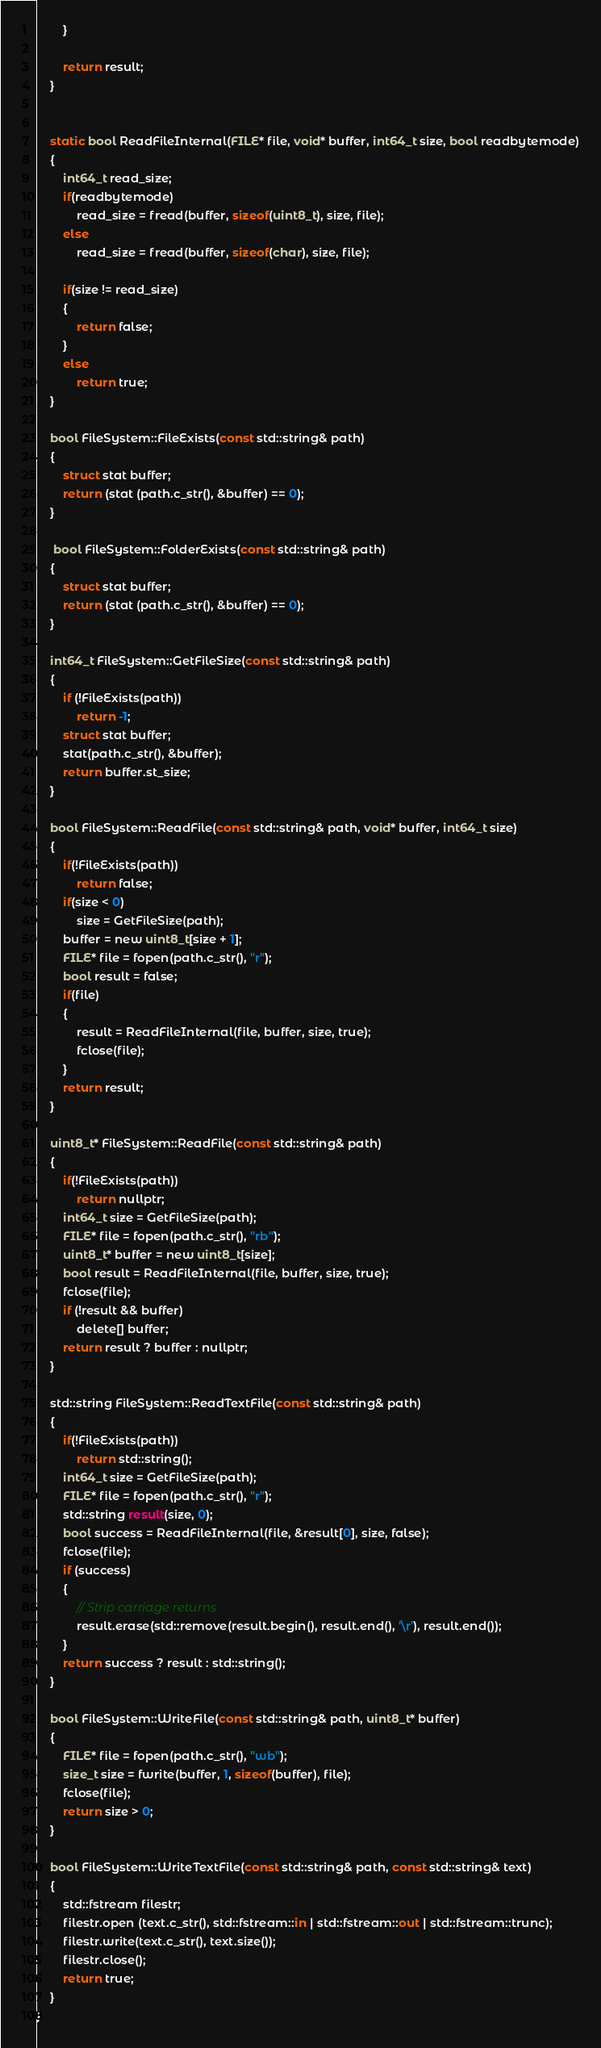Convert code to text. <code><loc_0><loc_0><loc_500><loc_500><_ObjectiveC_>        }
        
        return result;
    }


    static bool ReadFileInternal(FILE* file, void* buffer, int64_t size, bool readbytemode)
    {
        int64_t read_size;
        if(readbytemode)
            read_size = fread(buffer, sizeof(uint8_t), size, file);
        else
            read_size = fread(buffer, sizeof(char), size, file);

        if(size != read_size)
        {
            return false;
        }
        else
            return true;
    }

    bool FileSystem::FileExists(const std::string& path)
    {
        struct stat buffer;
        return (stat (path.c_str(), &buffer) == 0);
    }
	
	 bool FileSystem::FolderExists(const std::string& path)
    {
        struct stat buffer;
        return (stat (path.c_str(), &buffer) == 0);
    }

    int64_t FileSystem::GetFileSize(const std::string& path)
    {
        if (!FileExists(path))
            return -1;
        struct stat buffer;
        stat(path.c_str(), &buffer);
        return buffer.st_size;
    }

    bool FileSystem::ReadFile(const std::string& path, void* buffer, int64_t size)
    {
        if(!FileExists(path))
            return false;
        if(size < 0)
            size = GetFileSize(path);
        buffer = new uint8_t[size + 1];
        FILE* file = fopen(path.c_str(), "r");
        bool result = false;
        if(file)
        {
            result = ReadFileInternal(file, buffer, size, true);
            fclose(file);
        }
        return result;
    }

    uint8_t* FileSystem::ReadFile(const std::string& path)
    {
        if(!FileExists(path))
            return nullptr;
        int64_t size = GetFileSize(path);
        FILE* file = fopen(path.c_str(), "rb");
        uint8_t* buffer = new uint8_t[size];
        bool result = ReadFileInternal(file, buffer, size, true);
        fclose(file);
        if (!result && buffer)
            delete[] buffer;
        return result ? buffer : nullptr;
    }

    std::string FileSystem::ReadTextFile(const std::string& path)
    {
        if(!FileExists(path))
            return std::string();
        int64_t size = GetFileSize(path);
        FILE* file = fopen(path.c_str(), "r");
        std::string result(size, 0);
        bool success = ReadFileInternal(file, &result[0], size, false);
        fclose(file);
        if (success)
        {
            // Strip carriage returns
            result.erase(std::remove(result.begin(), result.end(), '\r'), result.end());
        }
        return success ? result : std::string();
    }

    bool FileSystem::WriteFile(const std::string& path, uint8_t* buffer)
    {
        FILE* file = fopen(path.c_str(), "wb");
        size_t size = fwrite(buffer, 1, sizeof(buffer), file);
        fclose(file);
        return size > 0;
    }

    bool FileSystem::WriteTextFile(const std::string& path, const std::string& text)
    {
        std::fstream filestr;
        filestr.open (text.c_str(), std::fstream::in | std::fstream::out | std::fstream::trunc);
        filestr.write(text.c_str(), text.size());
        filestr.close();
        return true;
    }
}
</code> 